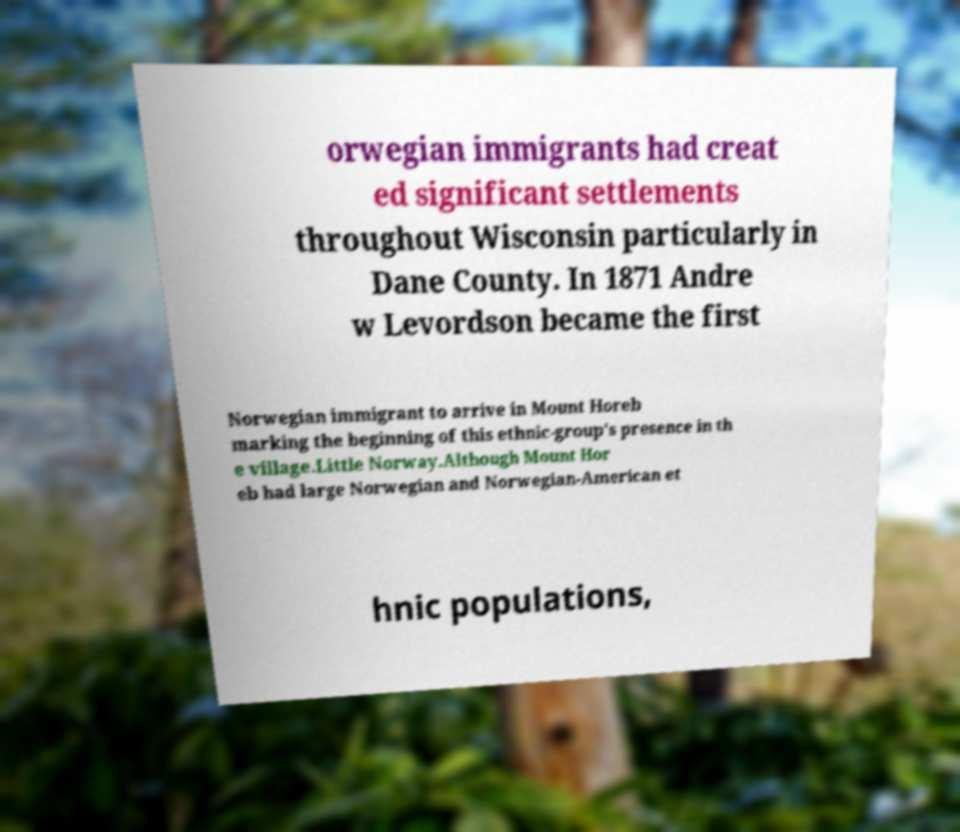Can you read and provide the text displayed in the image?This photo seems to have some interesting text. Can you extract and type it out for me? orwegian immigrants had creat ed significant settlements throughout Wisconsin particularly in Dane County. In 1871 Andre w Levordson became the first Norwegian immigrant to arrive in Mount Horeb marking the beginning of this ethnic-group's presence in th e village.Little Norway.Although Mount Hor eb had large Norwegian and Norwegian-American et hnic populations, 